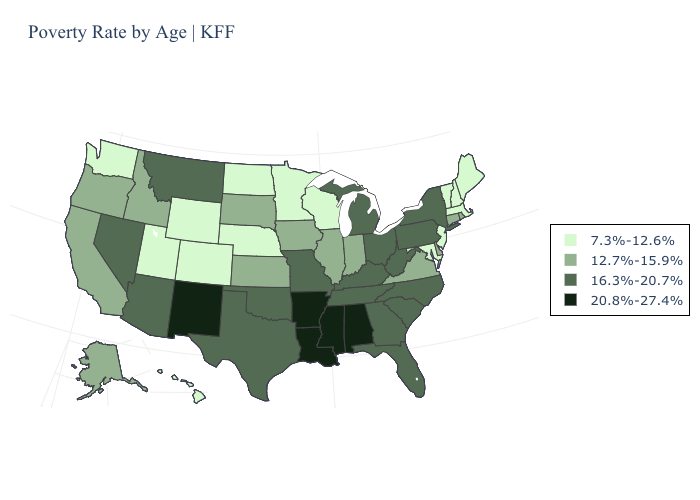What is the value of Wyoming?
Give a very brief answer. 7.3%-12.6%. What is the value of Florida?
Write a very short answer. 16.3%-20.7%. Which states have the lowest value in the South?
Write a very short answer. Maryland. Does Missouri have the highest value in the USA?
Concise answer only. No. Does the first symbol in the legend represent the smallest category?
Answer briefly. Yes. Does Florida have a lower value than New Mexico?
Give a very brief answer. Yes. What is the value of Georgia?
Keep it brief. 16.3%-20.7%. Which states have the highest value in the USA?
Answer briefly. Alabama, Arkansas, Louisiana, Mississippi, New Mexico. What is the value of Maryland?
Write a very short answer. 7.3%-12.6%. What is the value of Michigan?
Give a very brief answer. 16.3%-20.7%. Does the map have missing data?
Concise answer only. No. Does Tennessee have the lowest value in the USA?
Answer briefly. No. Does Nevada have the highest value in the West?
Short answer required. No. Among the states that border Montana , which have the highest value?
Short answer required. Idaho, South Dakota. 